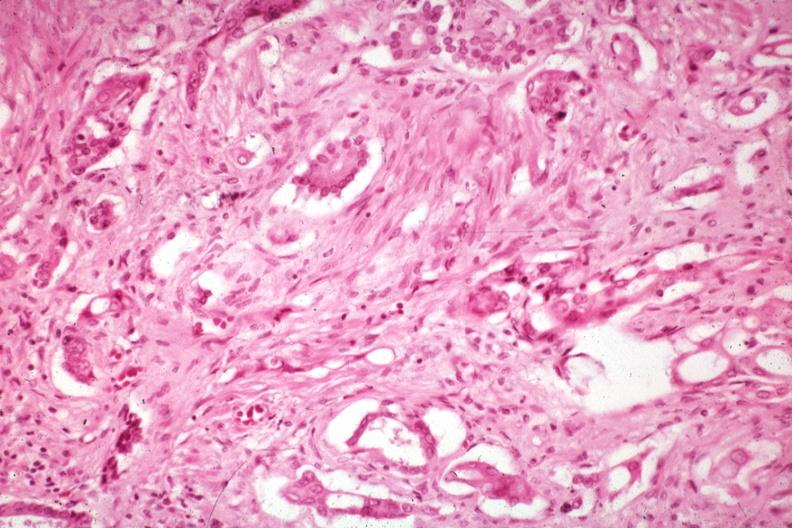re siamese twins prominent in the stroma?
Answer the question using a single word or phrase. No 